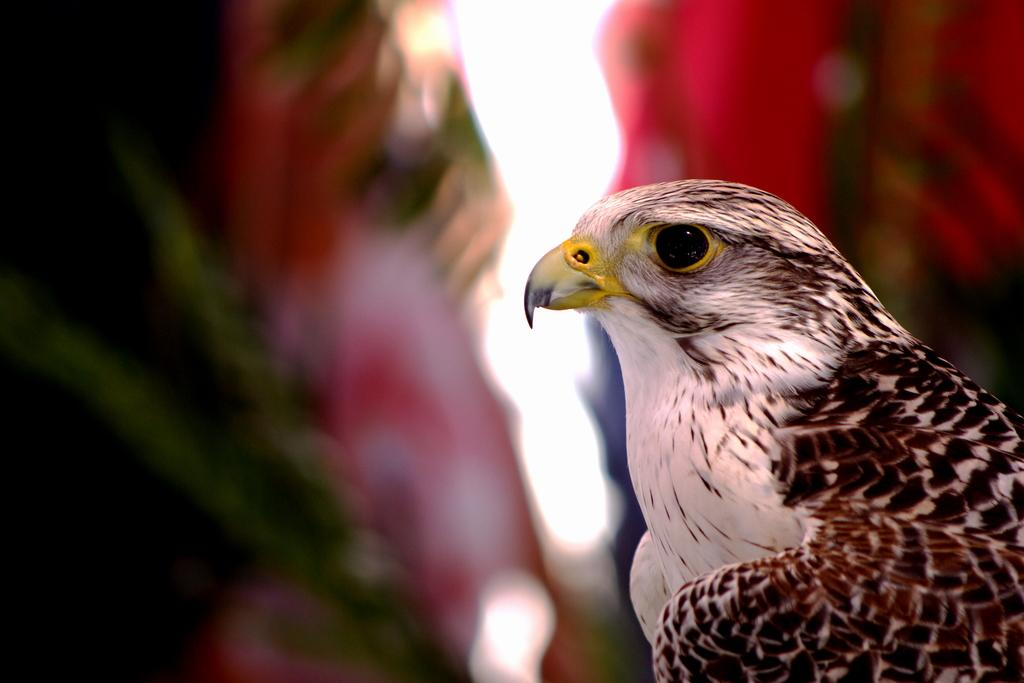What is the main subject of the image? The main subject of the image is an eagle. Where is the eagle located in the image? The eagle is in the middle of the image. What type of floor can be seen beneath the eagle in the image? There is no floor visible in the image, as it appears to be an eagle in flight or perched in a natural setting. What type of wren is sitting next to the eagle in the image? There is no wren present in the image; only the eagle is visible. 